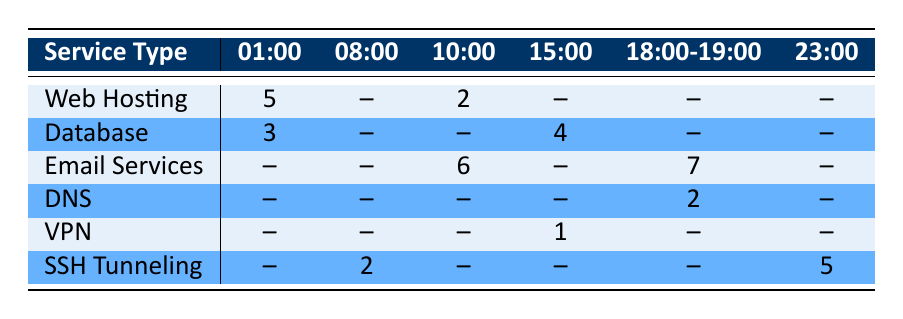What is the downtime occurrence for Web Hosting at 01:00? Referring to the table, under the "Web Hosting" row and "01:00" column, the value is 5.
Answer: 5 What services experience downtime at 10:00? By looking at the "10:00" column, the services with recorded downtime are "Web Hosting" with 2 occurrences and "Email Services" with 6 occurrences.
Answer: Web Hosting (2), Email Services (6) Does DNS have any recorded downtime at 01:00? Searching the table for "DNS" in the "01:00" column shows that there is no value recorded (indicated by the -- symbol).
Answer: No What is the total downtime occurrence for Email Services during the specified hours? The recorded downtimes for Email Services are 6 at 10:00 and 7 at 19:00. Adding these gives us 6 + 7 = 13.
Answer: 13 At what hour did SSH Tunneling see the most downtime occurrences? SSH Tunneling has recorded downtimes at 08:00 (2 occurrences) and 23:00 (5 occurrences). Comparing these, 5 at 23:00 is the highest.
Answer: 23:00 How many total downtime occurrences were recorded for services between 18:00 and 19:00? In the "18:00-19:00" column, the only service with recorded downtime is "Email Services" (7 occurrences) and "DNS" (2 occurrences). Adding these gives us 2 + 7 = 9.
Answer: 9 Are there any services that experienced downtime at 15:00? Checking the "15:00" column, both "Database" (4 occurrences) and "VPN" (1 occurrence) have recorded downtimes.
Answer: Yes Which type of service has the highest total downtime occurrence? Summing the downtimes: Web Hosting (5), Database (7), Email Services (13), DNS (2), VPN (1), SSH Tunneling (7). The highest total is Email Services with 13.
Answer: Email Services What is the difference in downtime occurrences between Database at 01:00 and Web Hosting at 10:00? The downtimes are 3 for Database at 01:00 and 2 for Web Hosting at 10:00. Subtracting, 3 - 2 = 1 gives a difference of 1.
Answer: 1 